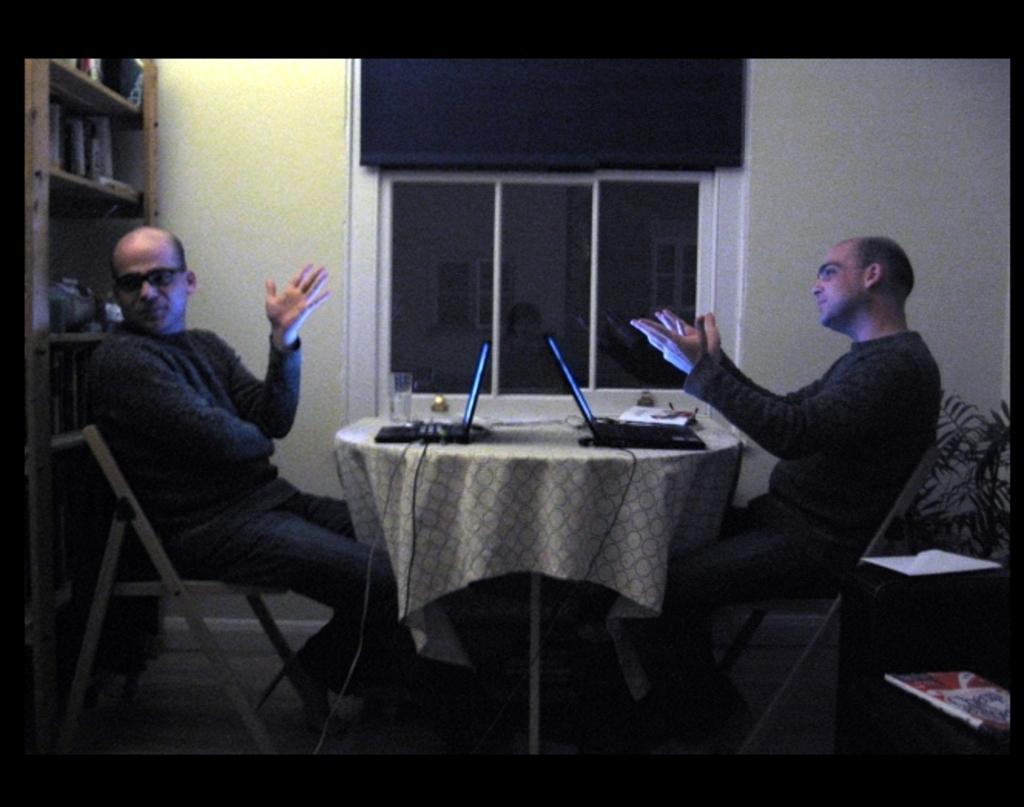Describe this image in one or two sentences. On the background we can see wall, window, curtain. We can see two men sitting on chair in front a table and on the table we can see a glass of water, laptop. This is a floor. Here we can see a book, houseplant. We can see books arranged in a sequence manner at the left side of the picture. 